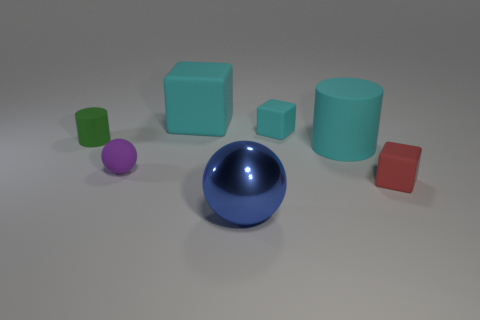Is there anything else that is the same material as the large blue thing?
Make the answer very short. No. What number of rubber objects are to the left of the big cyan matte thing that is in front of the small green thing?
Give a very brief answer. 4. There is a cyan thing in front of the green object; is its shape the same as the tiny green object that is behind the red cube?
Offer a terse response. Yes. How many small objects are left of the red matte block?
Keep it short and to the point. 3. Are the ball behind the tiny red thing and the big block made of the same material?
Your answer should be very brief. Yes. What color is the large thing that is the same shape as the tiny purple matte thing?
Your answer should be compact. Blue. What shape is the red matte object?
Offer a terse response. Cube. How many things are large blue rubber spheres or small blocks?
Offer a terse response. 2. Do the cube that is left of the blue object and the big matte object that is on the right side of the small cyan thing have the same color?
Offer a very short reply. Yes. What number of other objects are the same shape as the blue thing?
Offer a terse response. 1. 